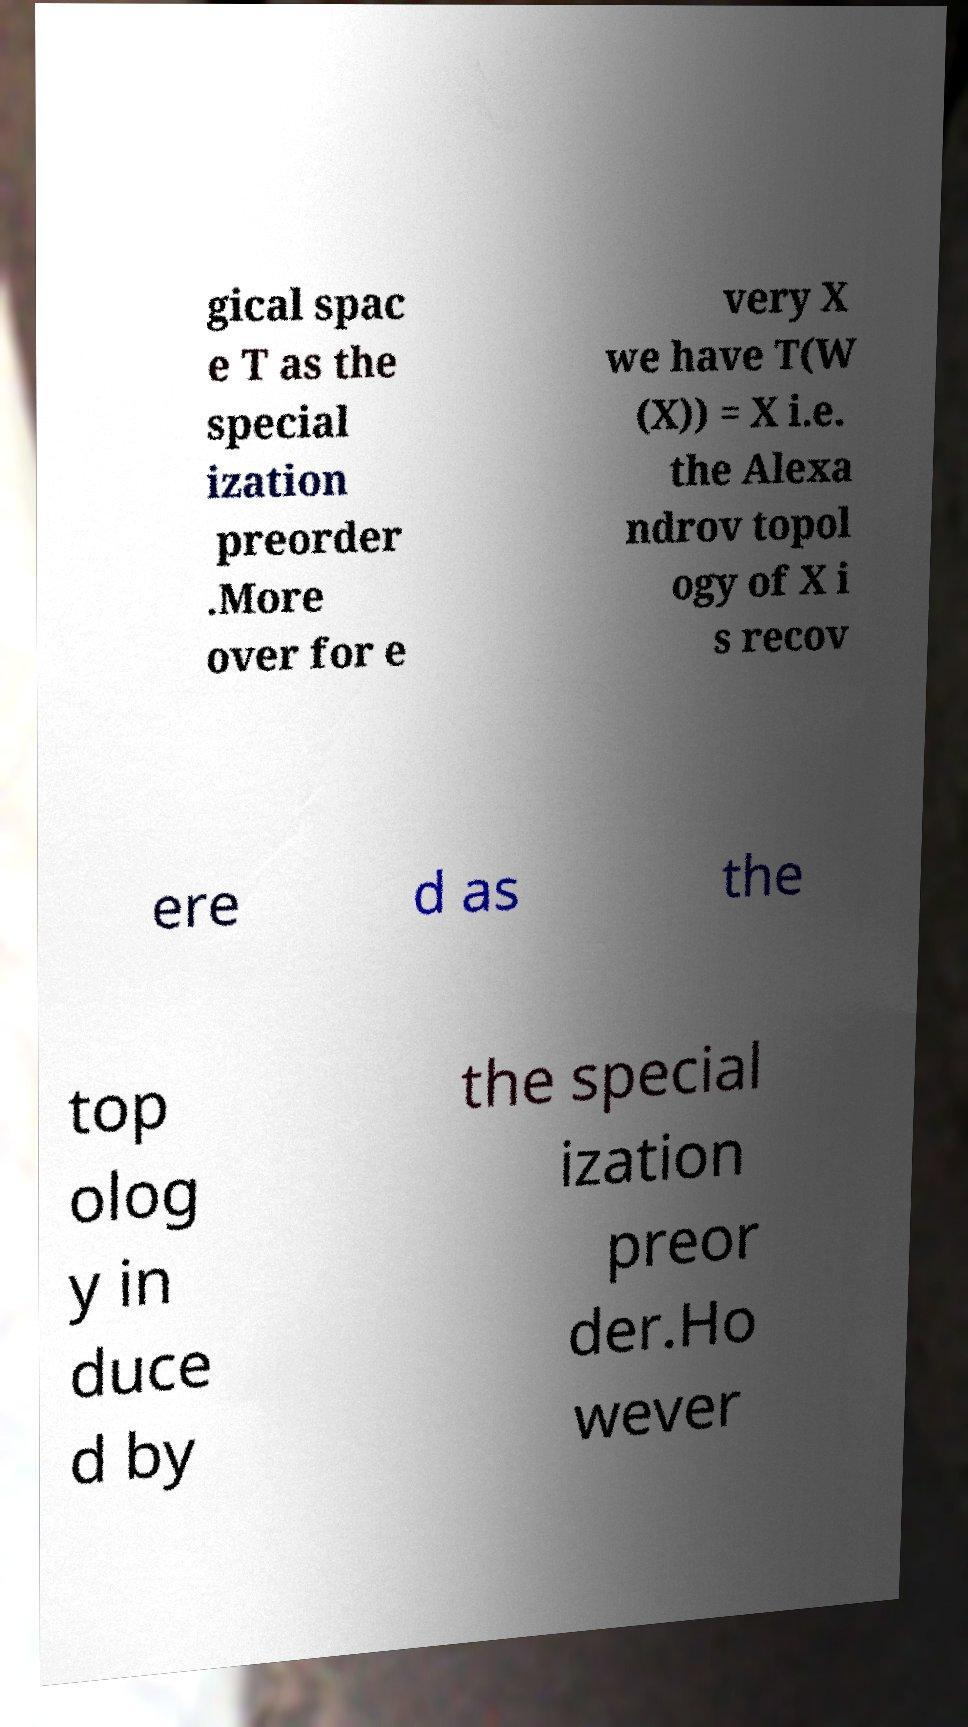Please read and relay the text visible in this image. What does it say? gical spac e T as the special ization preorder .More over for e very X we have T(W (X)) = X i.e. the Alexa ndrov topol ogy of X i s recov ere d as the top olog y in duce d by the special ization preor der.Ho wever 